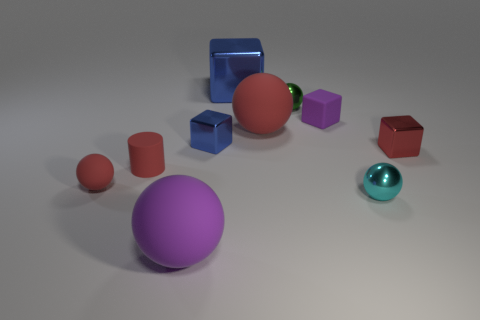Do the metallic block that is on the right side of the purple block and the tiny green metallic sphere have the same size?
Ensure brevity in your answer.  Yes. How many other objects are the same material as the small green ball?
Provide a short and direct response. 4. Is the number of tiny purple matte blocks greater than the number of red rubber things?
Your response must be concise. No. There is a blue object to the left of the blue object behind the large rubber thing behind the purple sphere; what is it made of?
Provide a succinct answer. Metal. Does the small rubber sphere have the same color as the large shiny cube?
Your answer should be compact. No. Are there any big matte objects that have the same color as the small matte cylinder?
Offer a terse response. Yes. What is the shape of the purple matte object that is the same size as the red matte cylinder?
Keep it short and to the point. Cube. Is the number of big yellow spheres less than the number of purple balls?
Keep it short and to the point. Yes. What number of red things are the same size as the cyan metal object?
Your answer should be very brief. 3. There is a small shiny object that is the same color as the matte cylinder; what is its shape?
Keep it short and to the point. Cube. 